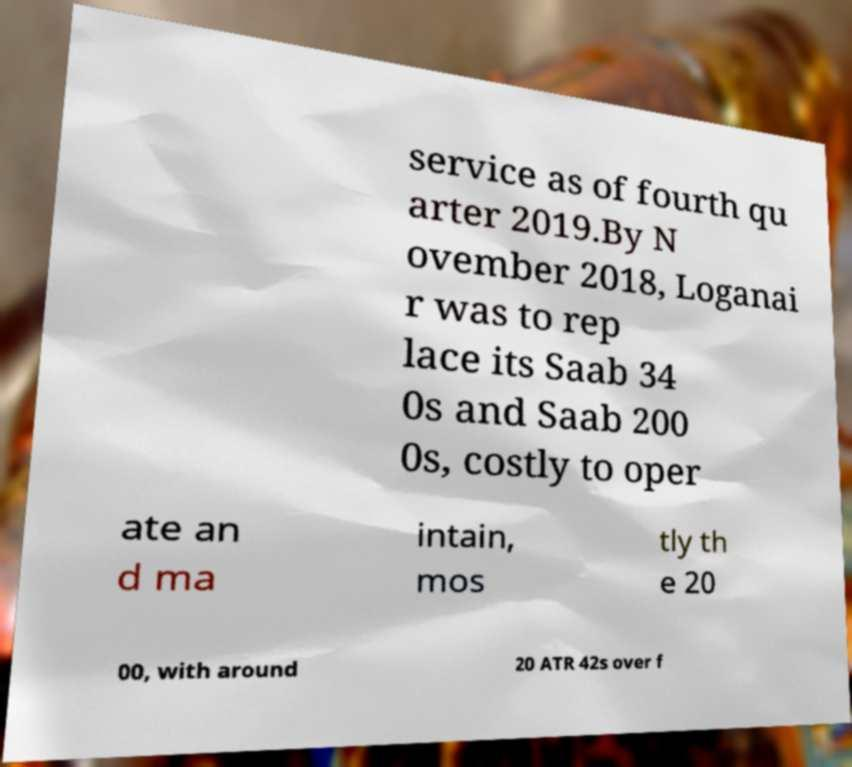I need the written content from this picture converted into text. Can you do that? service as of fourth qu arter 2019.By N ovember 2018, Loganai r was to rep lace its Saab 34 0s and Saab 200 0s, costly to oper ate an d ma intain, mos tly th e 20 00, with around 20 ATR 42s over f 